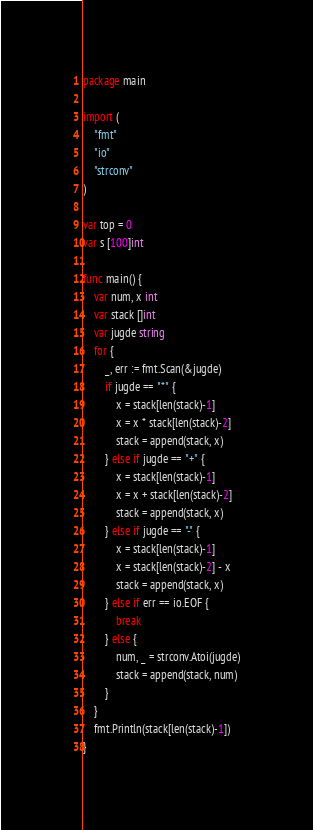Convert code to text. <code><loc_0><loc_0><loc_500><loc_500><_Go_>package main

import (
	"fmt"
	"io"
	"strconv"
)

var top = 0
var s [100]int

func main() {
	var num, x int
	var stack []int
	var jugde string
	for {
		_, err := fmt.Scan(&jugde)
		if jugde == "*" {
			x = stack[len(stack)-1]
			x = x * stack[len(stack)-2]
			stack = append(stack, x)
		} else if jugde == "+" {
			x = stack[len(stack)-1]
			x = x + stack[len(stack)-2]
			stack = append(stack, x)
		} else if jugde == "-" {
			x = stack[len(stack)-1]
			x = stack[len(stack)-2] - x
			stack = append(stack, x)
		} else if err == io.EOF {
			break
		} else {
			num, _ = strconv.Atoi(jugde)
			stack = append(stack, num)
		}
	}
	fmt.Println(stack[len(stack)-1])
}

</code> 